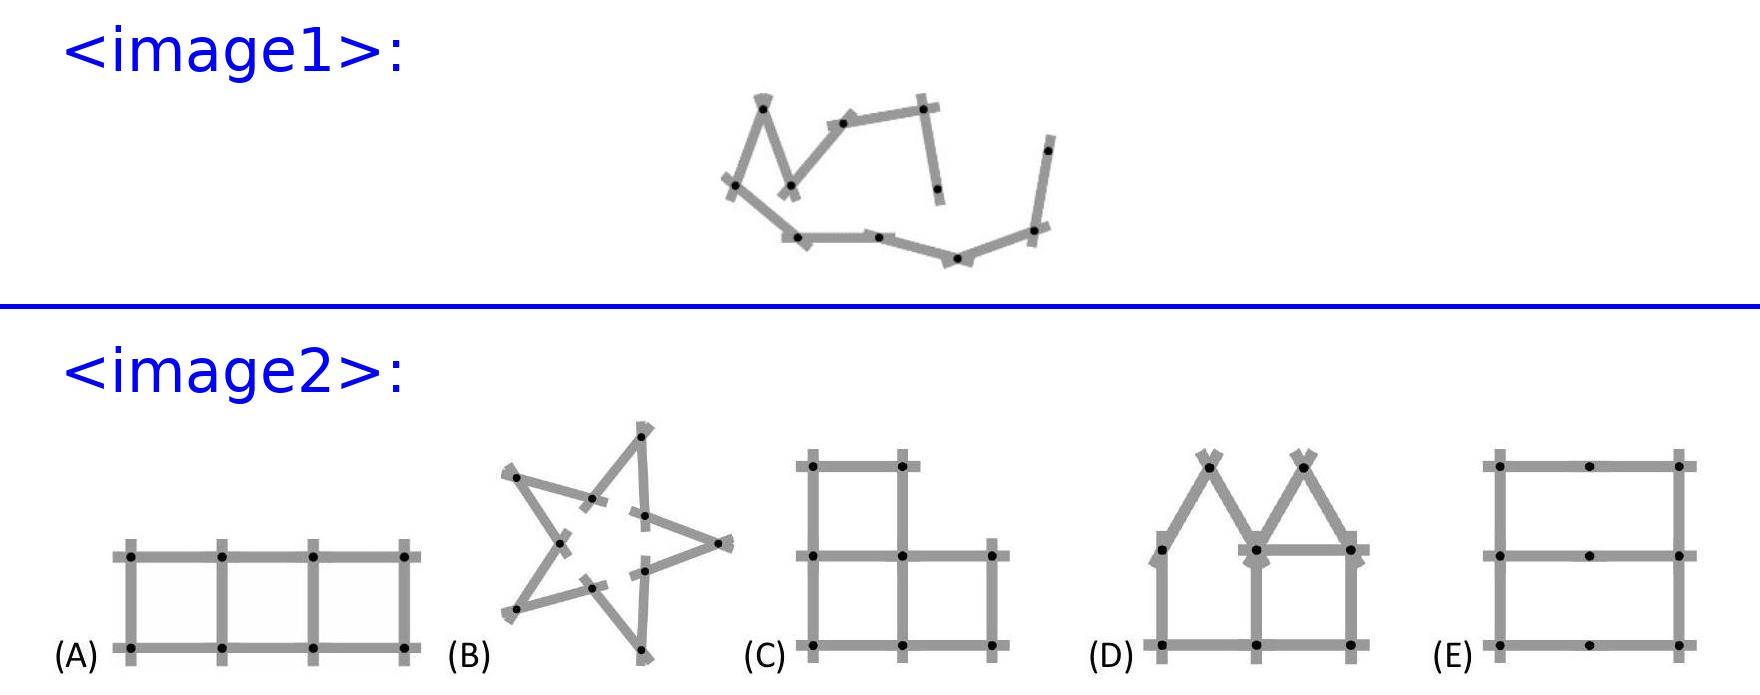<image2> Could you explain how the layout of figure D would specifically challenge Pia's use of the yardstick? Figure D creates an interesting challenge due to its two house structures with peaked roofs. The folding yardstick would need to be manipulated to create precise angles at the roof points and the base structure, which might be more complex than a straight or a fully symmetrical arrangement. 